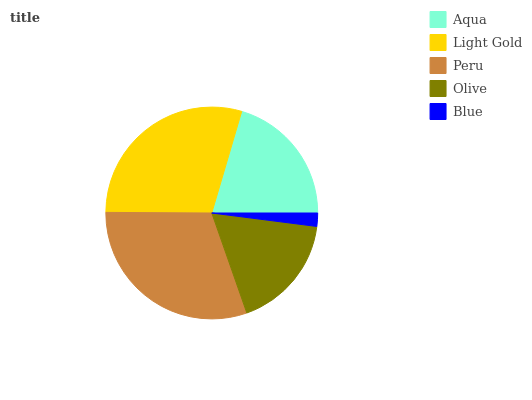Is Blue the minimum?
Answer yes or no. Yes. Is Peru the maximum?
Answer yes or no. Yes. Is Light Gold the minimum?
Answer yes or no. No. Is Light Gold the maximum?
Answer yes or no. No. Is Light Gold greater than Aqua?
Answer yes or no. Yes. Is Aqua less than Light Gold?
Answer yes or no. Yes. Is Aqua greater than Light Gold?
Answer yes or no. No. Is Light Gold less than Aqua?
Answer yes or no. No. Is Aqua the high median?
Answer yes or no. Yes. Is Aqua the low median?
Answer yes or no. Yes. Is Blue the high median?
Answer yes or no. No. Is Light Gold the low median?
Answer yes or no. No. 